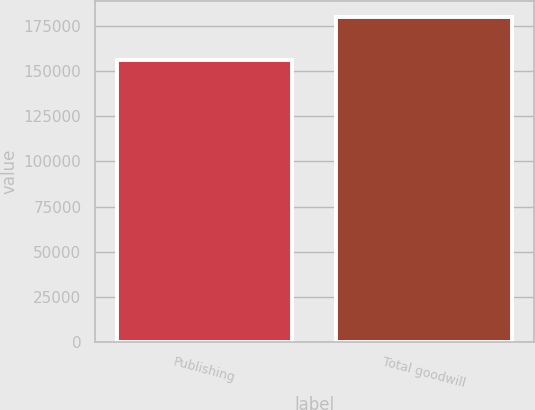Convert chart. <chart><loc_0><loc_0><loc_500><loc_500><bar_chart><fcel>Publishing<fcel>Total goodwill<nl><fcel>156169<fcel>179893<nl></chart> 